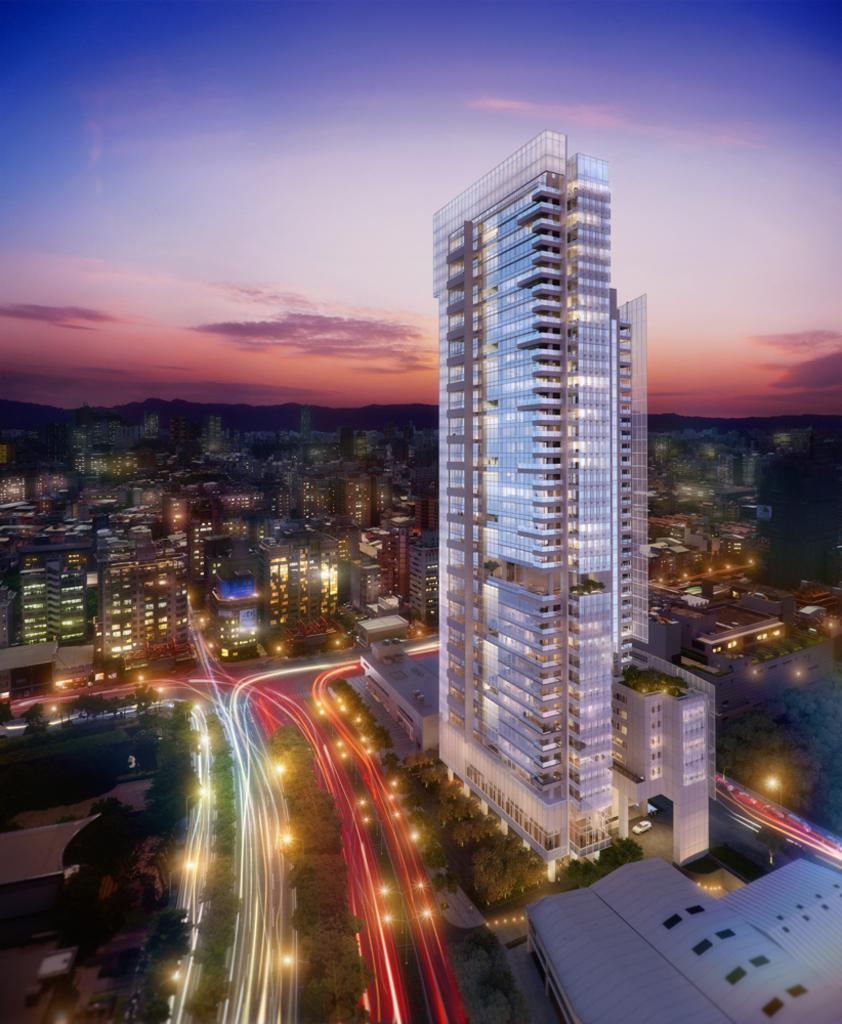What type of structures can be seen in the image? There are buildings in the image. What feature do the buildings have? The buildings have windows. What can be seen illuminated in the image? There are lights visible in the image. What type of pathway is present in the image? There is a road in the image. What type of vegetation is present in the image? There are trees in the image. What is visible above the structures and vegetation? The sky is visible in the image. What type of butter is being used to grease the wing of the airplane in the image? There is no airplane or butter present in the image; it features buildings, lights, a road, trees, and the sky. 